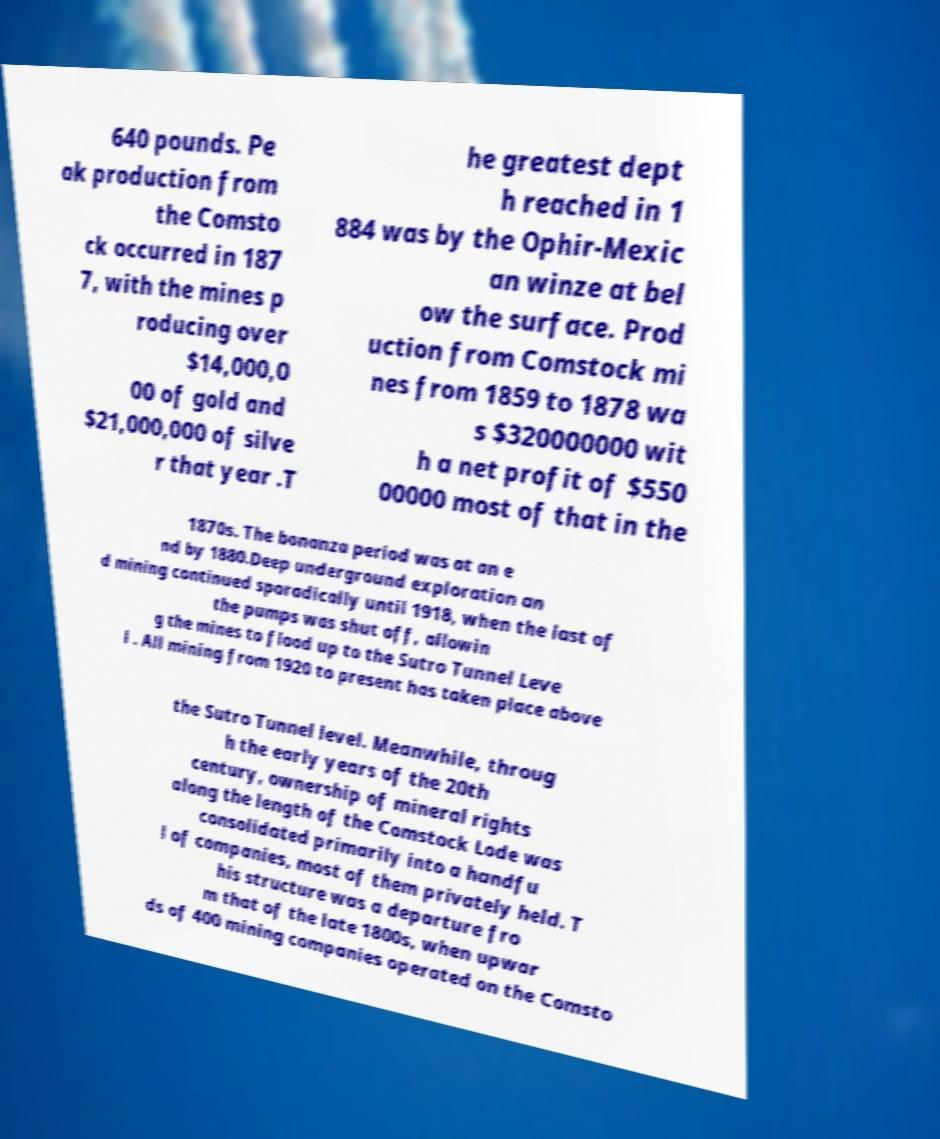For documentation purposes, I need the text within this image transcribed. Could you provide that? 640 pounds. Pe ak production from the Comsto ck occurred in 187 7, with the mines p roducing over $14,000,0 00 of gold and $21,000,000 of silve r that year .T he greatest dept h reached in 1 884 was by the Ophir-Mexic an winze at bel ow the surface. Prod uction from Comstock mi nes from 1859 to 1878 wa s $320000000 wit h a net profit of $550 00000 most of that in the 1870s. The bonanza period was at an e nd by 1880.Deep underground exploration an d mining continued sporadically until 1918, when the last of the pumps was shut off, allowin g the mines to flood up to the Sutro Tunnel Leve l . All mining from 1920 to present has taken place above the Sutro Tunnel level. Meanwhile, throug h the early years of the 20th century, ownership of mineral rights along the length of the Comstock Lode was consolidated primarily into a handfu l of companies, most of them privately held. T his structure was a departure fro m that of the late 1800s, when upwar ds of 400 mining companies operated on the Comsto 